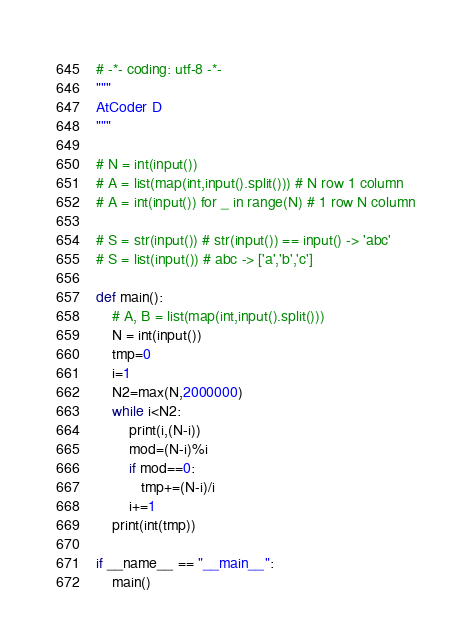Convert code to text. <code><loc_0><loc_0><loc_500><loc_500><_Python_># -*- coding: utf-8 -*-
"""
AtCoder D
"""

# N = int(input())
# A = list(map(int,input().split())) # N row 1 column
# A = int(input()) for _ in range(N) # 1 row N column

# S = str(input()) # str(input()) == input() -> 'abc'
# S = list(input()) # abc -> ['a','b','c']

def main():
    # A, B = list(map(int,input().split()))
    N = int(input())
    tmp=0
    i=1
    N2=max(N,2000000)
    while i<N2:
        print(i,(N-i))
        mod=(N-i)%i
        if mod==0:
           tmp+=(N-i)/i
        i+=1
    print(int(tmp))
    
if __name__ == "__main__":
    main()</code> 